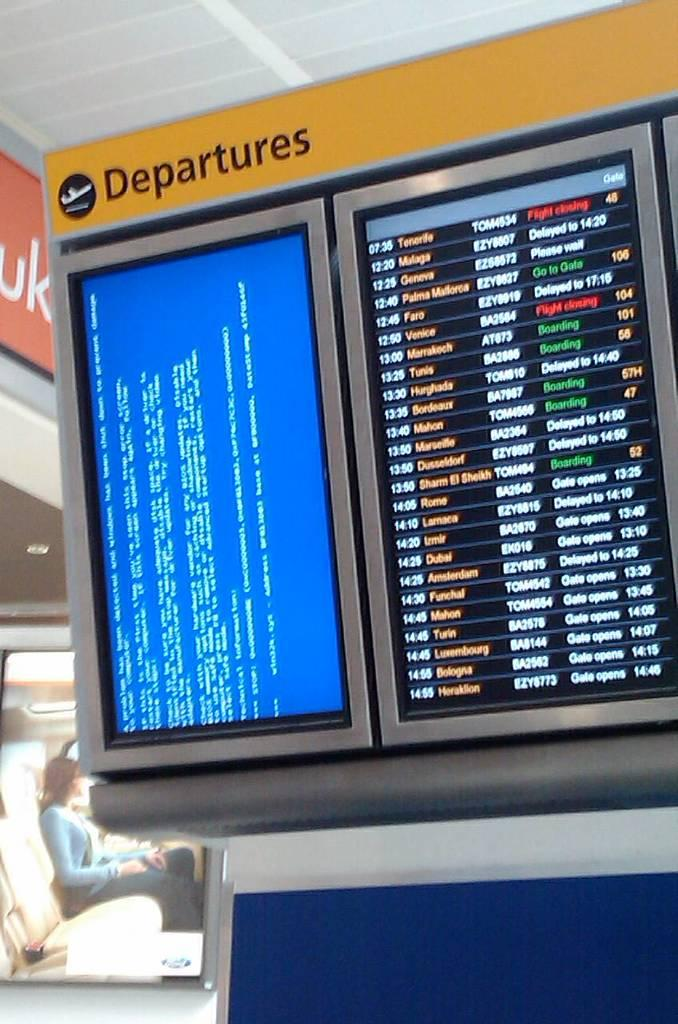How many screens are visible in the image? There are two screens in the image. What is the position of the human in the image? The human is sitting on the left side of the image. What can be seen in the background of the image? There is a hoarding in the background of the image. What color is present at the bottom of the image? There is a blue color at the bottom of the image. Can you see any geese playing chess on the screens in the image? There are no geese or chess games present on the screens in the image. What type of shake is being offered at the hoarding in the background? There is no shake or any food item mentioned on the hoarding in the background; it only displays a hoarding. 